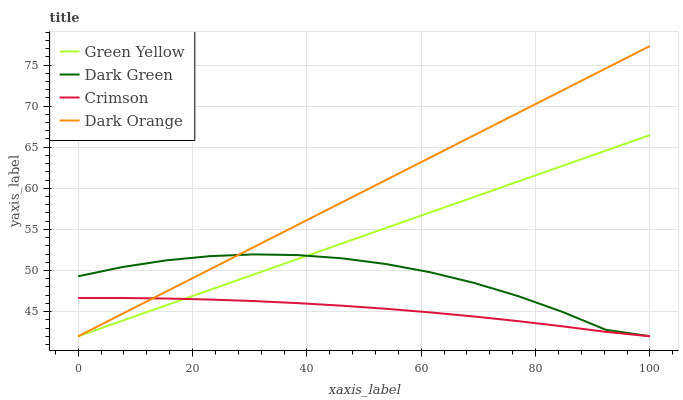Does Green Yellow have the minimum area under the curve?
Answer yes or no. No. Does Green Yellow have the maximum area under the curve?
Answer yes or no. No. Is Green Yellow the smoothest?
Answer yes or no. No. Is Green Yellow the roughest?
Answer yes or no. No. Does Green Yellow have the highest value?
Answer yes or no. No. 